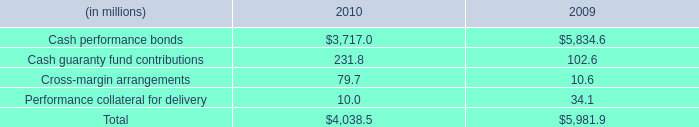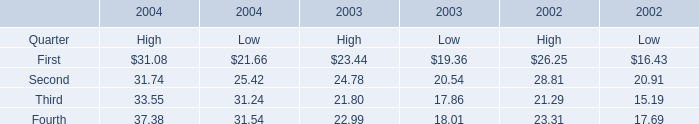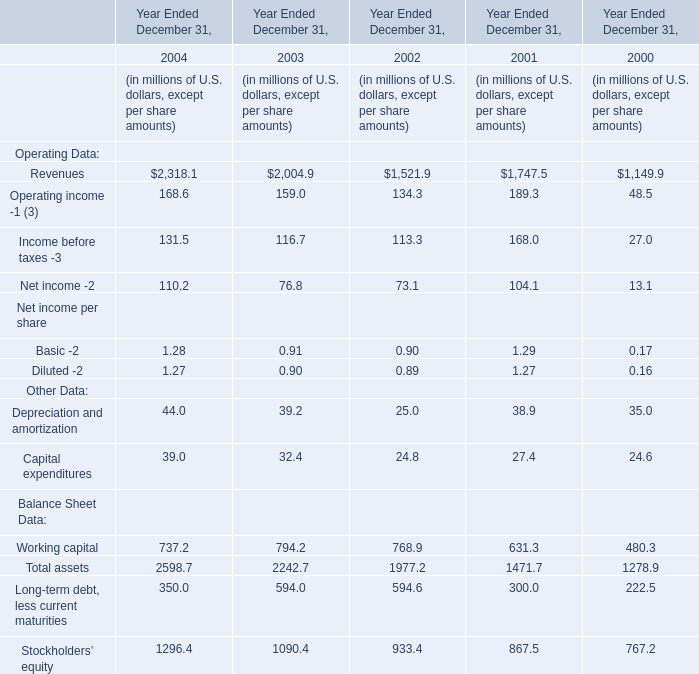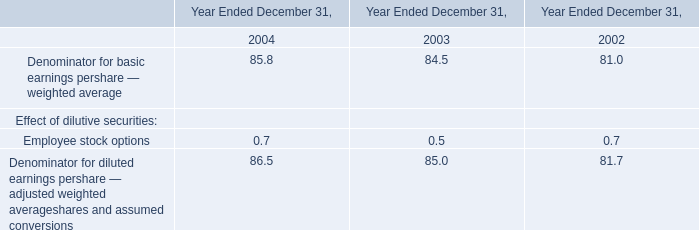What is the sum of the Revenues in the year where the Total assets is the most? (in million) 
Answer: 2318.1. 